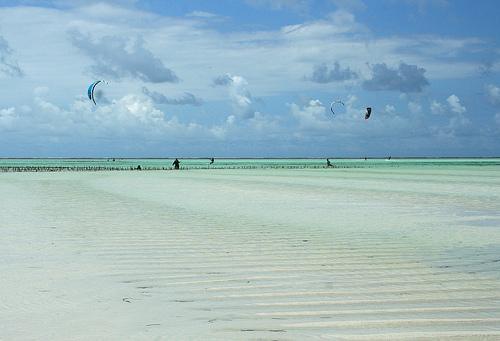How many people in the picture?
Give a very brief answer. 7. 